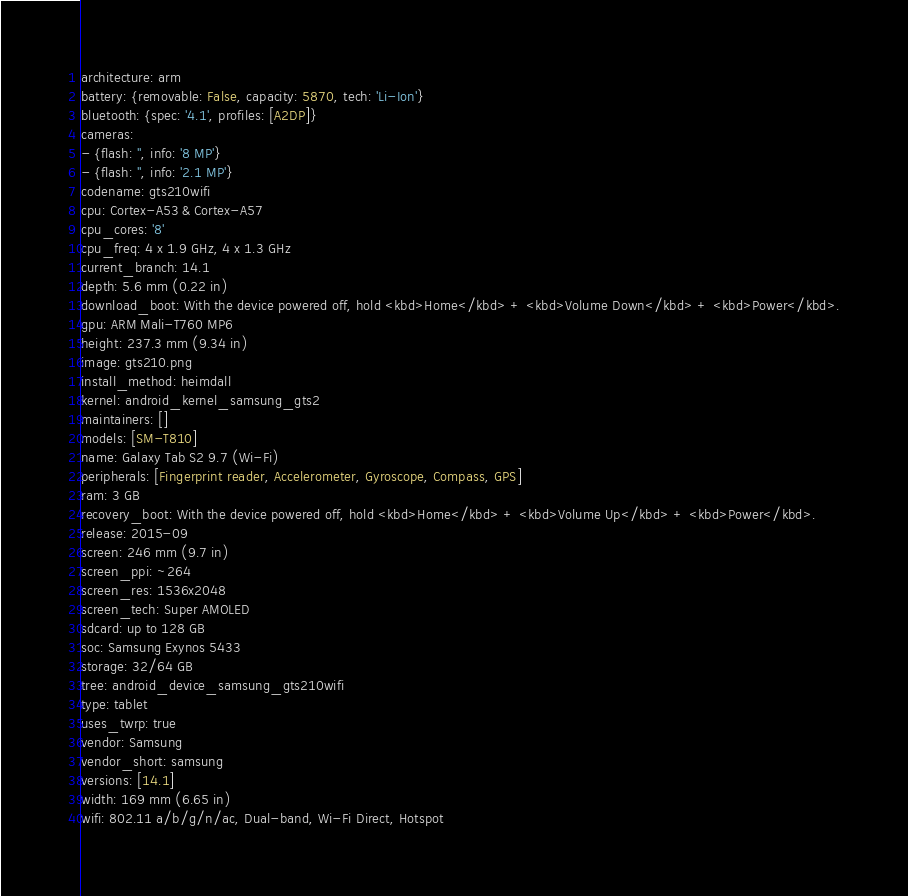<code> <loc_0><loc_0><loc_500><loc_500><_YAML_>architecture: arm
battery: {removable: False, capacity: 5870, tech: 'Li-Ion'}
bluetooth: {spec: '4.1', profiles: [A2DP]}
cameras:
- {flash: '', info: '8 MP'}
- {flash: '', info: '2.1 MP'}
codename: gts210wifi
cpu: Cortex-A53 & Cortex-A57
cpu_cores: '8'
cpu_freq: 4 x 1.9 GHz, 4 x 1.3 GHz
current_branch: 14.1
depth: 5.6 mm (0.22 in)
download_boot: With the device powered off, hold <kbd>Home</kbd> + <kbd>Volume Down</kbd> + <kbd>Power</kbd>.
gpu: ARM Mali-T760 MP6
height: 237.3 mm (9.34 in)
image: gts210.png
install_method: heimdall
kernel: android_kernel_samsung_gts2
maintainers: []
models: [SM-T810]
name: Galaxy Tab S2 9.7 (Wi-Fi)
peripherals: [Fingerprint reader, Accelerometer, Gyroscope, Compass, GPS]
ram: 3 GB
recovery_boot: With the device powered off, hold <kbd>Home</kbd> + <kbd>Volume Up</kbd> + <kbd>Power</kbd>.
release: 2015-09
screen: 246 mm (9.7 in)
screen_ppi: ~264
screen_res: 1536x2048
screen_tech: Super AMOLED
sdcard: up to 128 GB
soc: Samsung Exynos 5433
storage: 32/64 GB
tree: android_device_samsung_gts210wifi
type: tablet
uses_twrp: true
vendor: Samsung
vendor_short: samsung
versions: [14.1]
width: 169 mm (6.65 in)
wifi: 802.11 a/b/g/n/ac, Dual-band, Wi-Fi Direct, Hotspot
</code> 